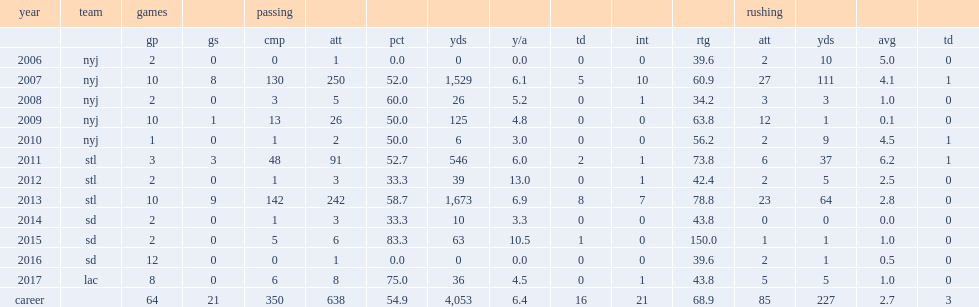How many touchdowns did clemen throw for 125 yards in 2009? 0.0. 